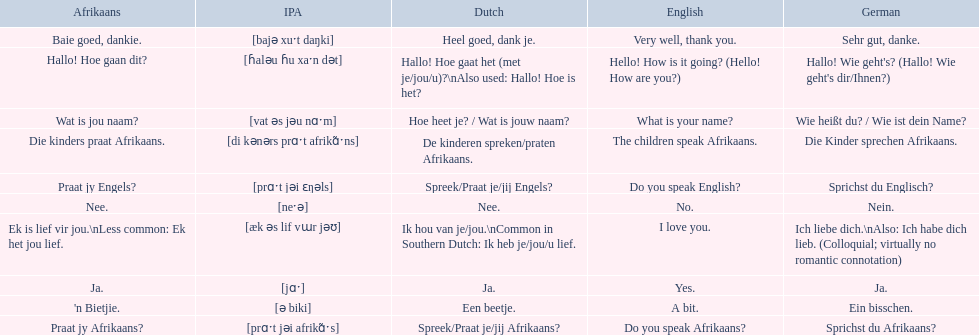What are the listed afrikaans phrases? Hallo! Hoe gaan dit?, Baie goed, dankie., Praat jy Afrikaans?, Praat jy Engels?, Ja., Nee., 'n Bietjie., Wat is jou naam?, Die kinders praat Afrikaans., Ek is lief vir jou.\nLess common: Ek het jou lief. Which is die kinders praat afrikaans? Die kinders praat Afrikaans. What is its german translation? Die Kinder sprechen Afrikaans. 